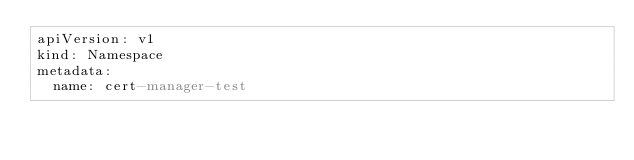<code> <loc_0><loc_0><loc_500><loc_500><_YAML_>apiVersion: v1
kind: Namespace
metadata:
  name: cert-manager-test
</code> 